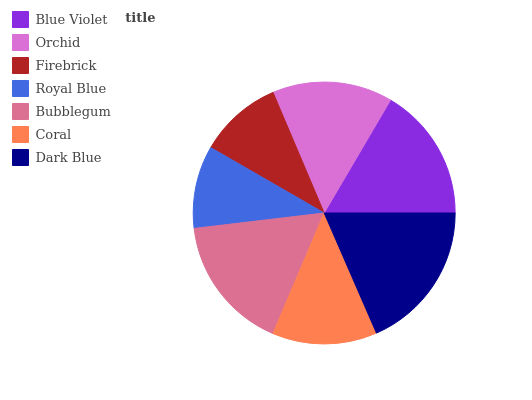Is Royal Blue the minimum?
Answer yes or no. Yes. Is Dark Blue the maximum?
Answer yes or no. Yes. Is Orchid the minimum?
Answer yes or no. No. Is Orchid the maximum?
Answer yes or no. No. Is Blue Violet greater than Orchid?
Answer yes or no. Yes. Is Orchid less than Blue Violet?
Answer yes or no. Yes. Is Orchid greater than Blue Violet?
Answer yes or no. No. Is Blue Violet less than Orchid?
Answer yes or no. No. Is Orchid the high median?
Answer yes or no. Yes. Is Orchid the low median?
Answer yes or no. Yes. Is Dark Blue the high median?
Answer yes or no. No. Is Coral the low median?
Answer yes or no. No. 